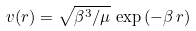Convert formula to latex. <formula><loc_0><loc_0><loc_500><loc_500>v ( r ) = \sqrt { \beta ^ { 3 } / \mu } \, \exp { ( - \beta \, r ) }</formula> 